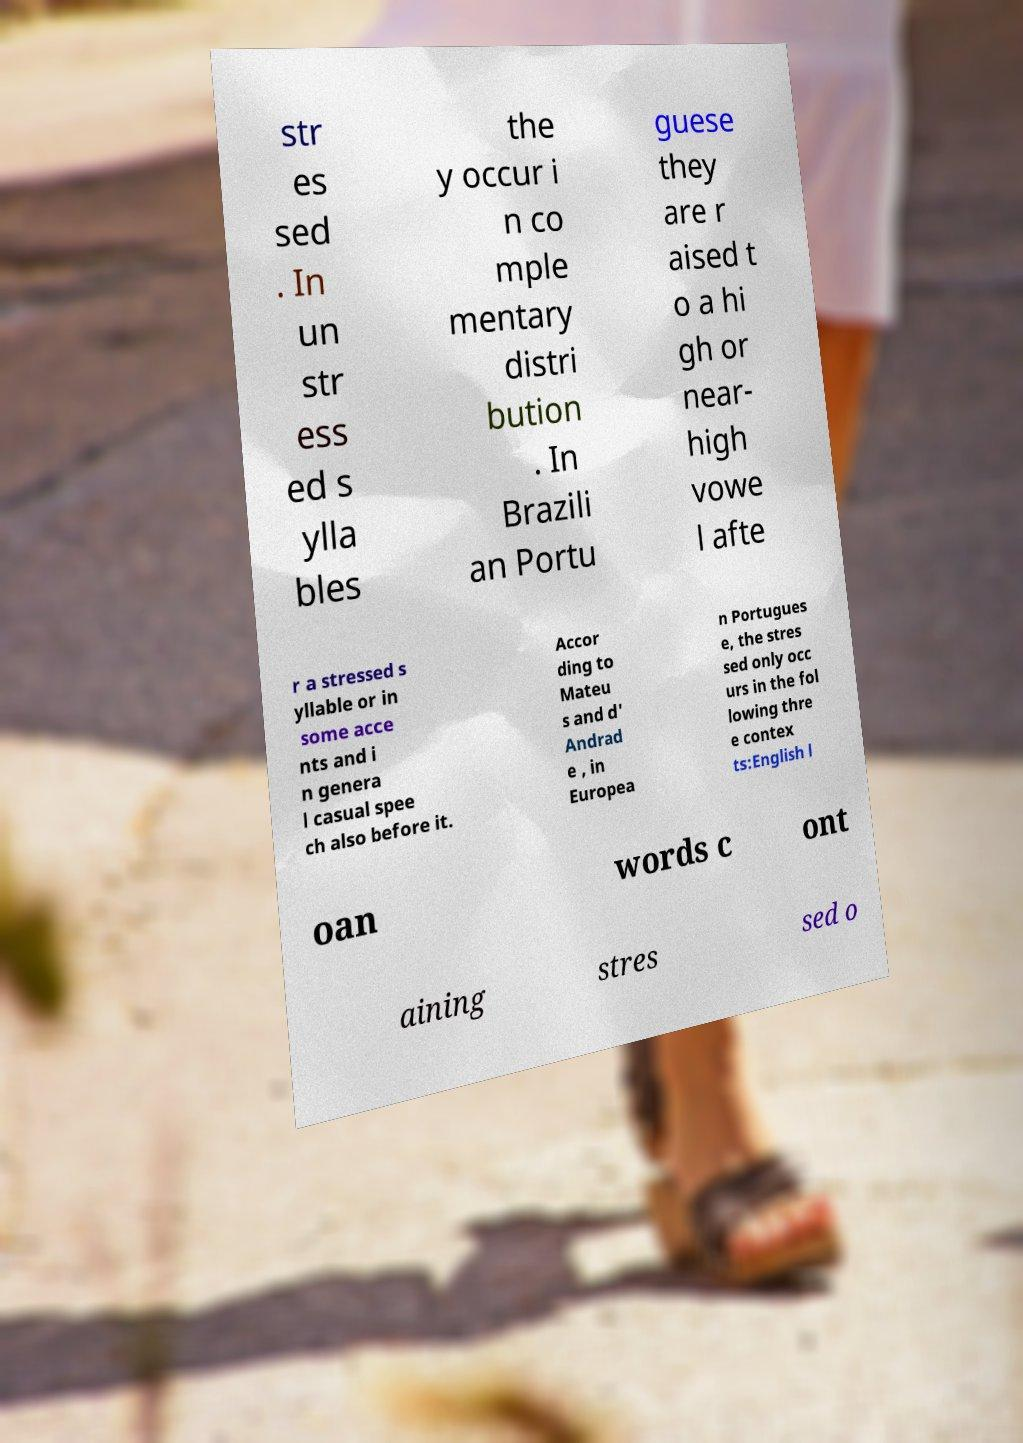For documentation purposes, I need the text within this image transcribed. Could you provide that? str es sed . In un str ess ed s ylla bles the y occur i n co mple mentary distri bution . In Brazili an Portu guese they are r aised t o a hi gh or near- high vowe l afte r a stressed s yllable or in some acce nts and i n genera l casual spee ch also before it. Accor ding to Mateu s and d' Andrad e , in Europea n Portugues e, the stres sed only occ urs in the fol lowing thre e contex ts:English l oan words c ont aining stres sed o 